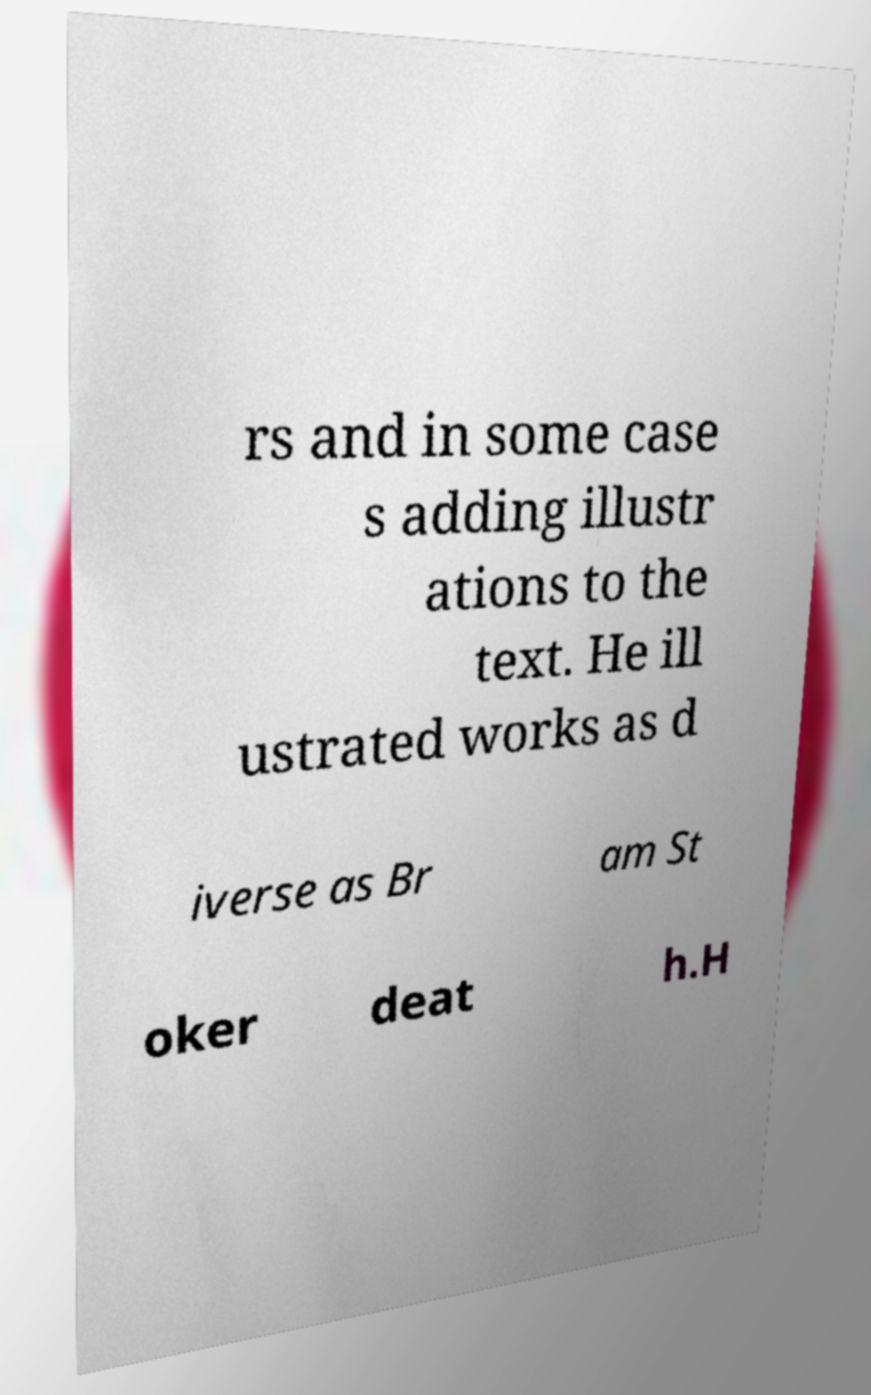Can you accurately transcribe the text from the provided image for me? rs and in some case s adding illustr ations to the text. He ill ustrated works as d iverse as Br am St oker deat h.H 